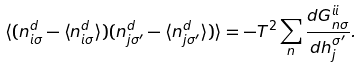Convert formula to latex. <formula><loc_0><loc_0><loc_500><loc_500>\langle ( n _ { i \sigma } ^ { d } - \langle n _ { i \sigma } ^ { d } \rangle ) ( n _ { j \sigma ^ { \prime } } ^ { d } - \langle n _ { j \sigma ^ { \prime } } ^ { d } \rangle ) \rangle = - T ^ { 2 } \sum _ { n } \frac { d G _ { n \sigma } ^ { i i } } { d h _ { j } ^ { \sigma ^ { \prime } } } .</formula> 